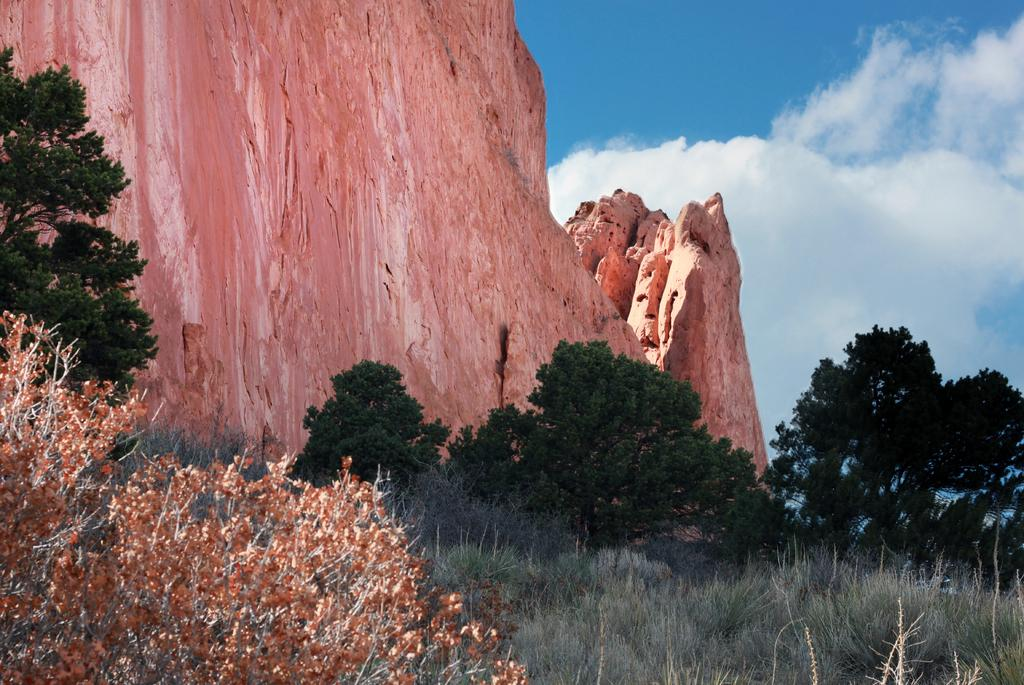What type of vegetation is present in the image? There is grass in the image. What other natural elements can be seen in the image? There are trees and stone hills in the image. What is the color of the sky in the image? The sky is blue in the image. Are there any weather conditions visible in the image? Yes, there are clouds in the sky in the image. What type of iron is being used by the judge in the image? There is no judge or iron present in the image. How does the sponge help the grass grow in the image? There is no sponge present in the image, and sponges do not directly affect grass growth. 